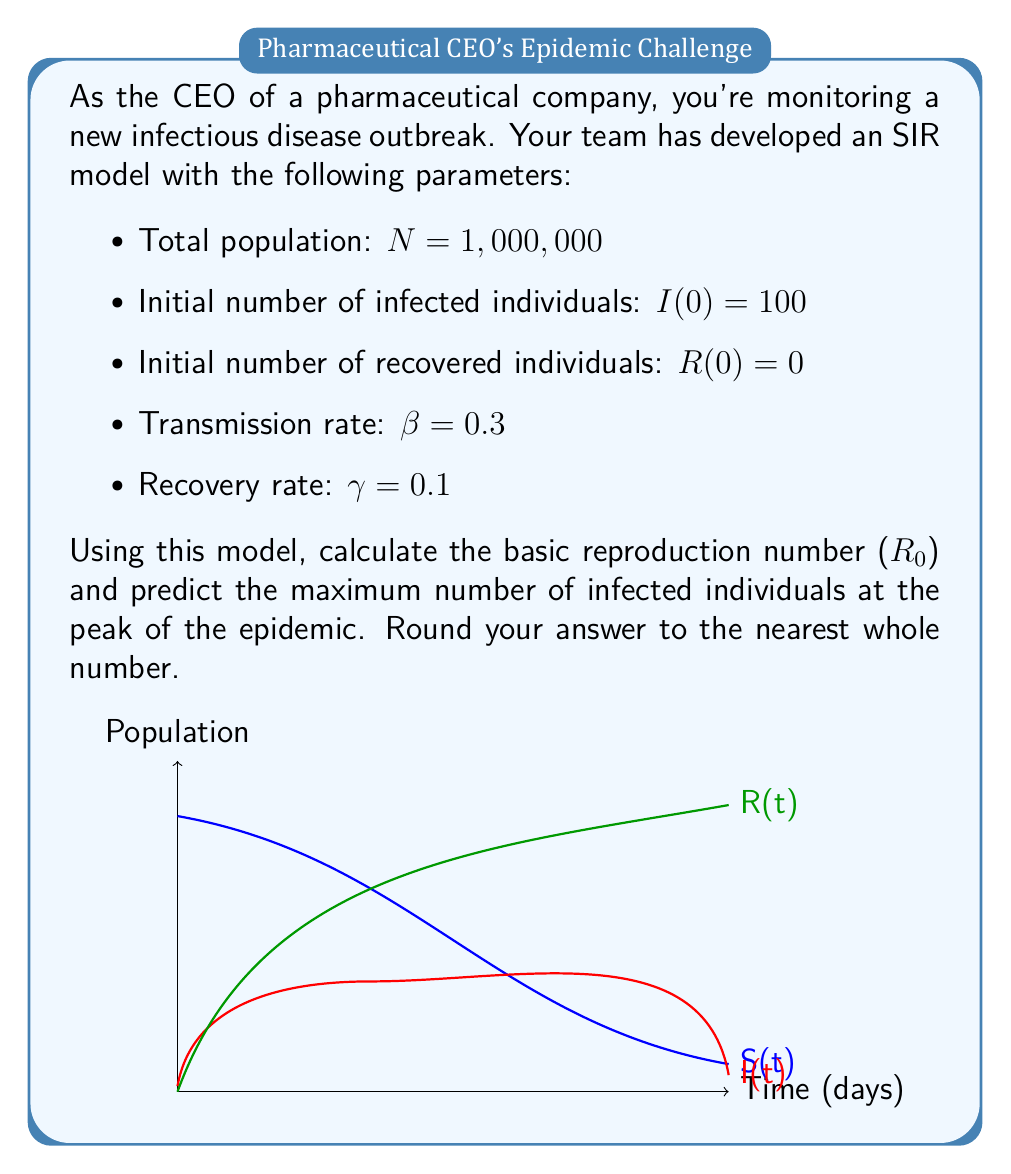Provide a solution to this math problem. Let's approach this step-by-step:

1. Calculate the basic reproduction number (R₀):
   The formula for R₀ in an SIR model is:
   $$R_0 = \frac{\beta}{\gamma}$$
   Substituting the given values:
   $$R_0 = \frac{0.3}{0.1} = 3$$

2. To find the maximum number of infected individuals, we need to determine when dI/dt = 0.
   The equation for dI/dt in the SIR model is:
   $$\frac{dI}{dt} = \beta SI - \gamma I$$

3. At the peak, dI/dt = 0, so:
   $$0 = \beta SI - \gamma I$$
   $$\beta SI = \gamma I$$
   $$S = \frac{\gamma}{\beta} = \frac{1}{R_0}$$

4. This means the peak occurs when the number of susceptible individuals is 1/R₀ of the total population:
   $$S_{peak} = \frac{N}{R_0} = \frac{1,000,000}{3} \approx 333,333$$

5. At this point, the number of recovered individuals is negligible compared to the total population, so we can approximate:
   $$I_{max} \approx N - S_{peak}$$

6. Calculate the maximum number of infected:
   $$I_{max} \approx 1,000,000 - 333,333 = 666,667$$

7. Rounding to the nearest whole number:
   $$I_{max} \approx 666,667$$
Answer: R₀ = 3, I_max ≈ 666,667 